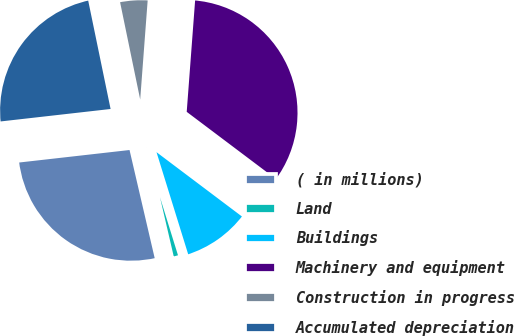Convert chart. <chart><loc_0><loc_0><loc_500><loc_500><pie_chart><fcel>( in millions)<fcel>Land<fcel>Buildings<fcel>Machinery and equipment<fcel>Construction in progress<fcel>Accumulated depreciation<nl><fcel>26.84%<fcel>1.15%<fcel>9.94%<fcel>34.07%<fcel>4.44%<fcel>23.55%<nl></chart> 